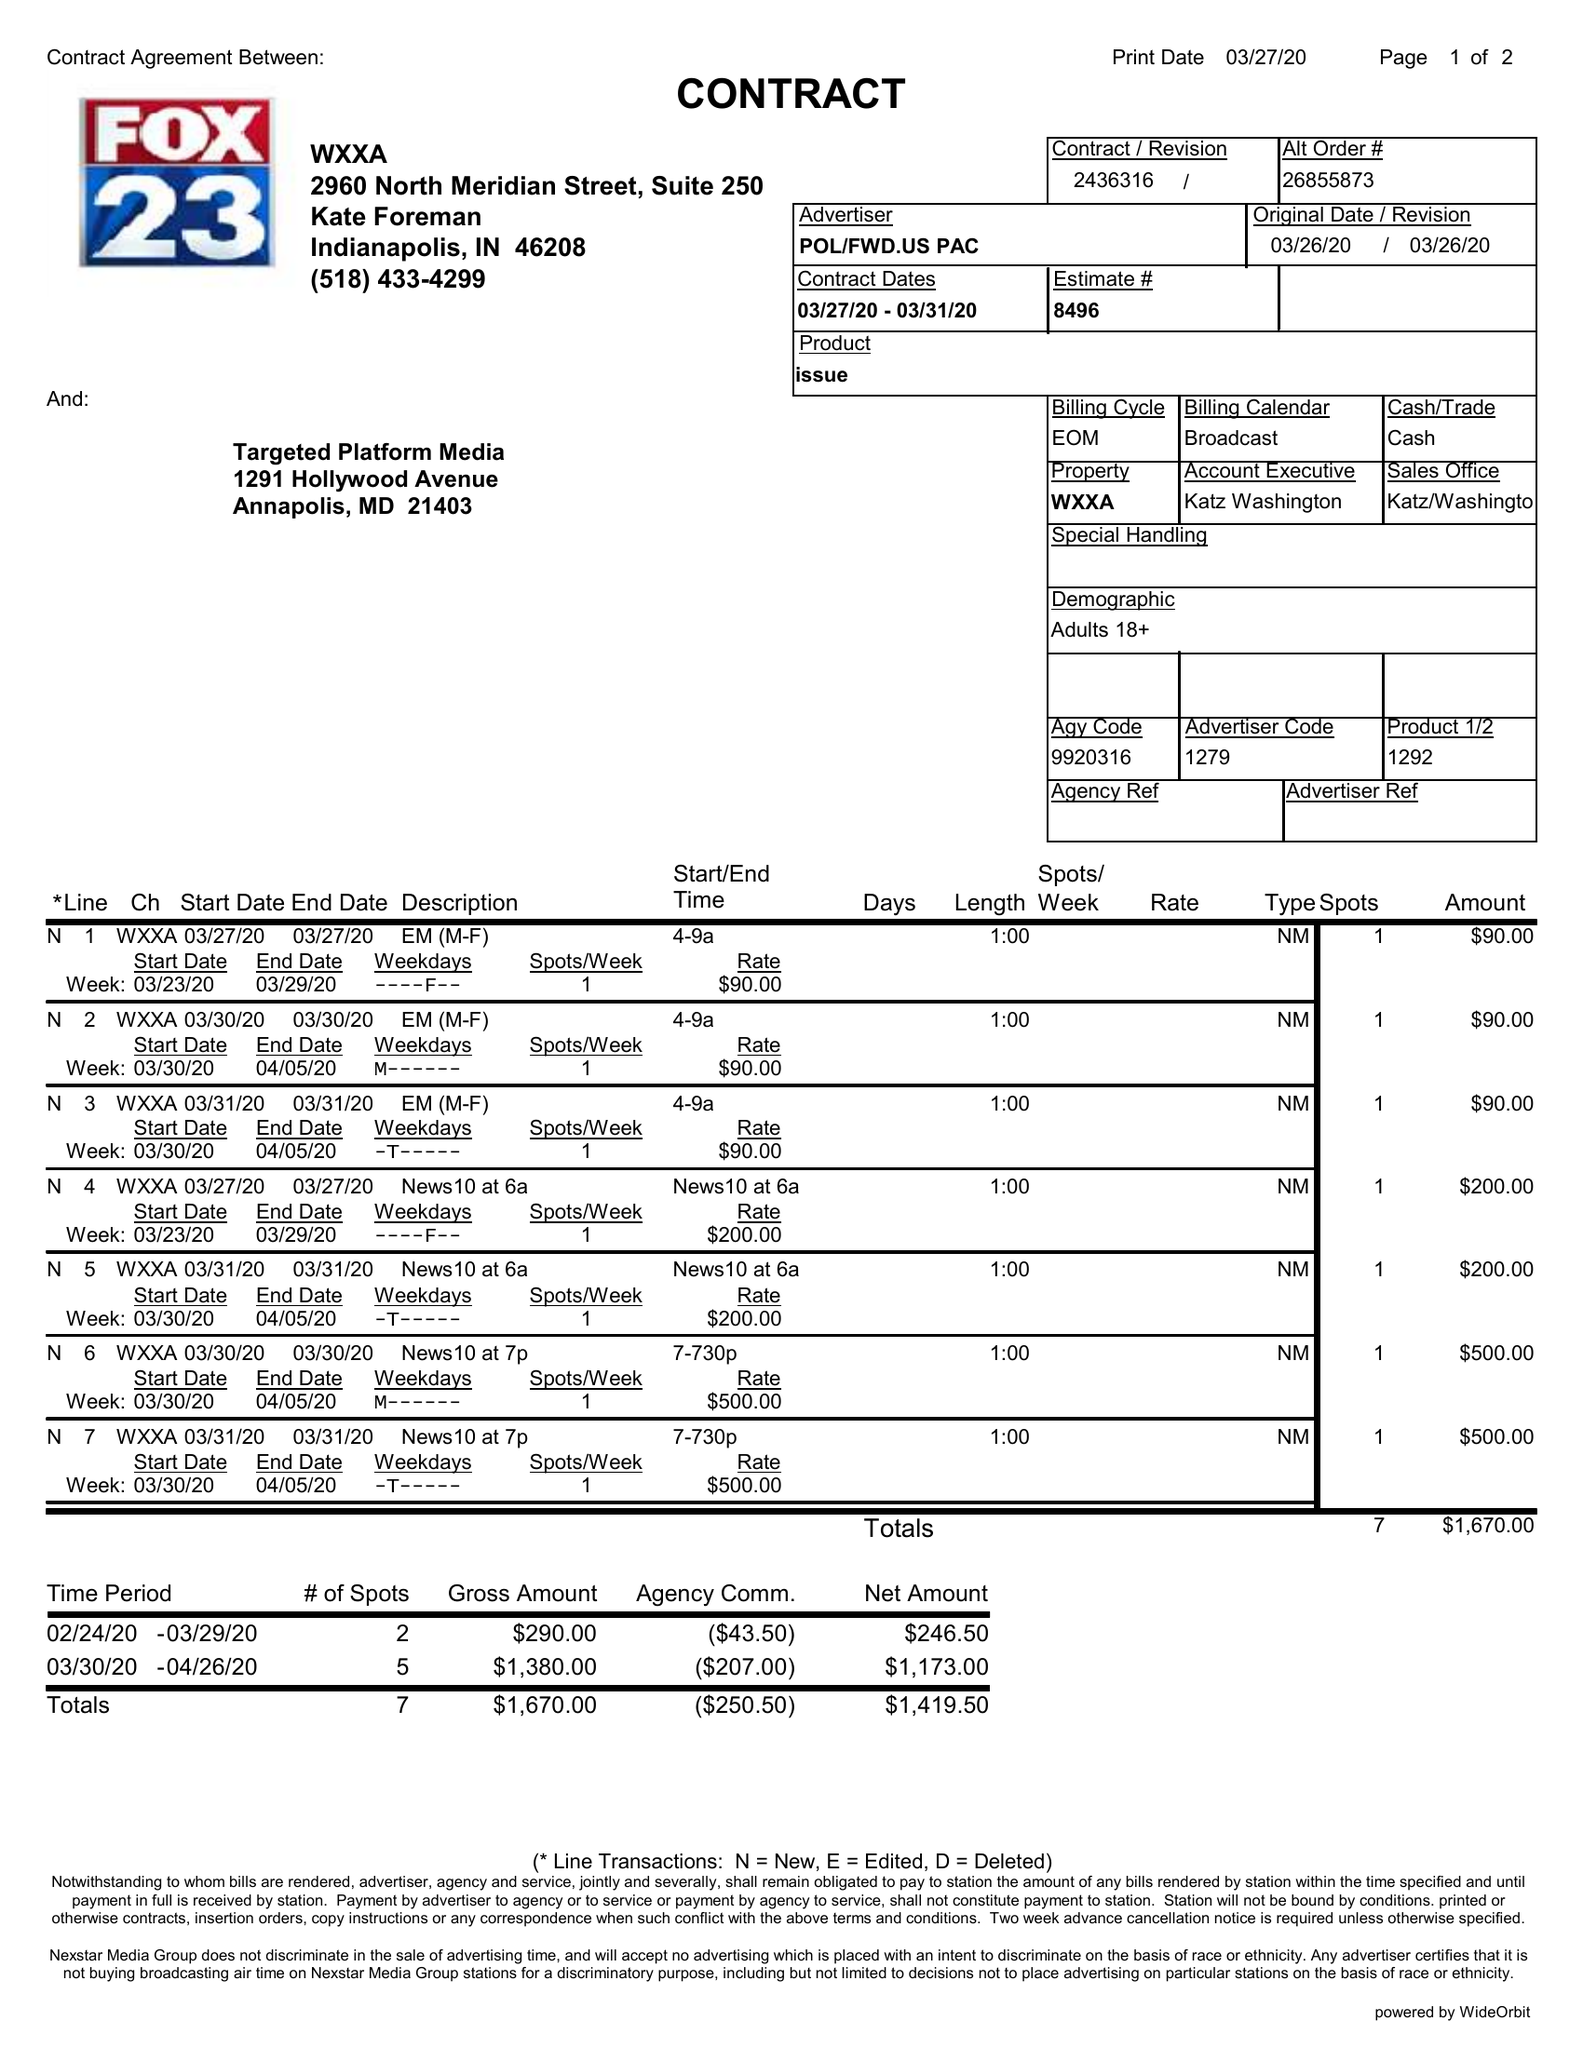What is the value for the advertiser?
Answer the question using a single word or phrase. POL/FWD.USPAC 